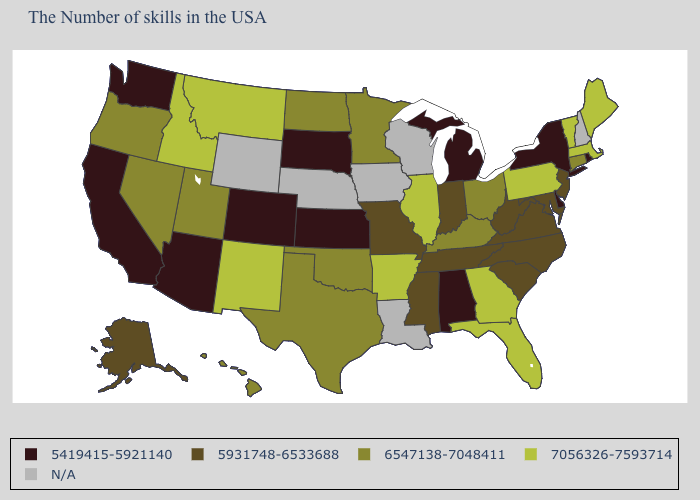Name the states that have a value in the range 7056326-7593714?
Write a very short answer. Maine, Massachusetts, Vermont, Pennsylvania, Florida, Georgia, Illinois, Arkansas, New Mexico, Montana, Idaho. What is the value of Massachusetts?
Quick response, please. 7056326-7593714. What is the value of North Dakota?
Quick response, please. 6547138-7048411. What is the lowest value in the USA?
Concise answer only. 5419415-5921140. Does Arizona have the lowest value in the USA?
Be succinct. Yes. Name the states that have a value in the range N/A?
Be succinct. New Hampshire, Wisconsin, Louisiana, Iowa, Nebraska, Wyoming. Name the states that have a value in the range 7056326-7593714?
Keep it brief. Maine, Massachusetts, Vermont, Pennsylvania, Florida, Georgia, Illinois, Arkansas, New Mexico, Montana, Idaho. Name the states that have a value in the range N/A?
Write a very short answer. New Hampshire, Wisconsin, Louisiana, Iowa, Nebraska, Wyoming. Does Illinois have the highest value in the MidWest?
Be succinct. Yes. Among the states that border New Jersey , does Delaware have the lowest value?
Be succinct. Yes. Name the states that have a value in the range 5931748-6533688?
Quick response, please. New Jersey, Maryland, Virginia, North Carolina, South Carolina, West Virginia, Indiana, Tennessee, Mississippi, Missouri, Alaska. What is the lowest value in states that border Oklahoma?
Concise answer only. 5419415-5921140. Name the states that have a value in the range 7056326-7593714?
Quick response, please. Maine, Massachusetts, Vermont, Pennsylvania, Florida, Georgia, Illinois, Arkansas, New Mexico, Montana, Idaho. Which states hav the highest value in the MidWest?
Give a very brief answer. Illinois. 